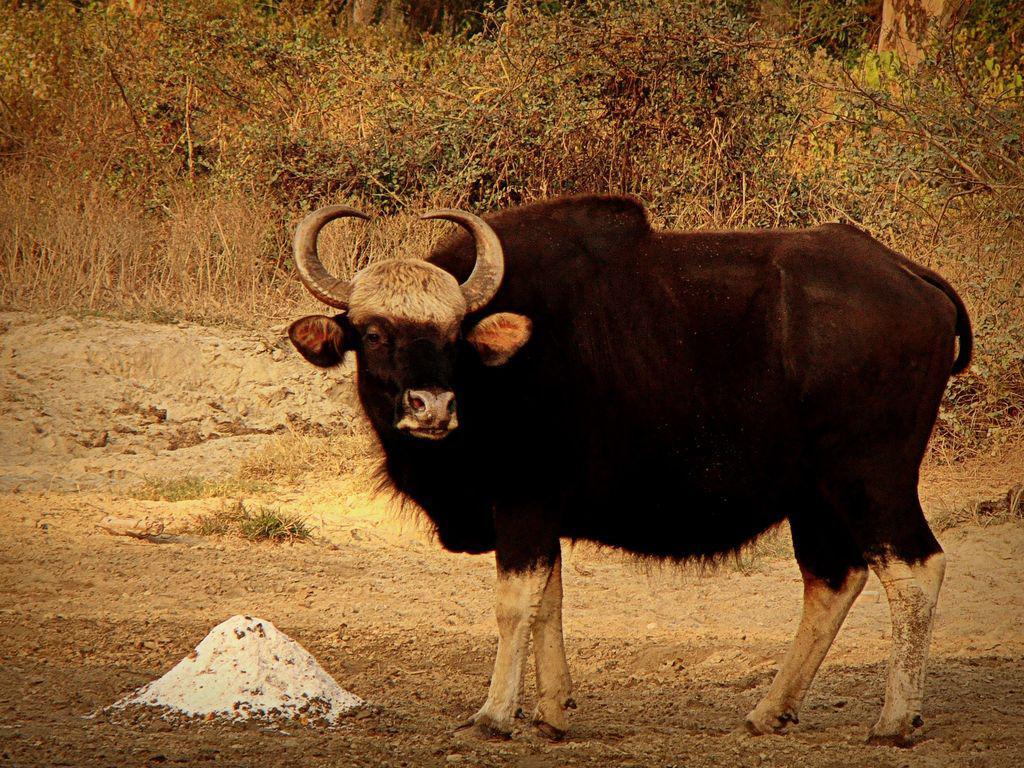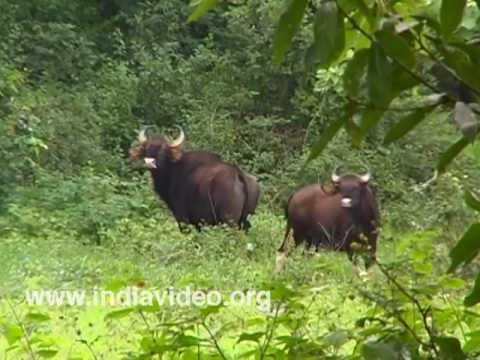The first image is the image on the left, the second image is the image on the right. For the images shown, is this caption "Each image contains exactly one horned animal, and the horned animal in the right image has its face turned to the camera." true? Answer yes or no. No. 